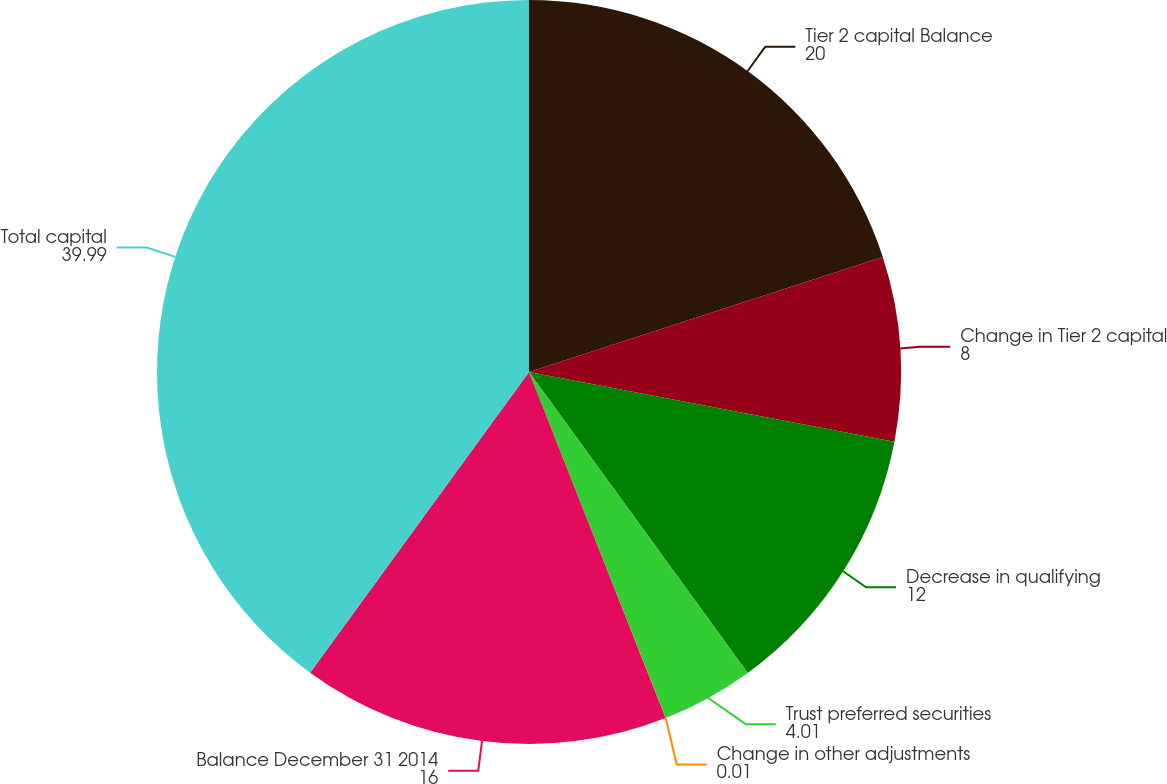<chart> <loc_0><loc_0><loc_500><loc_500><pie_chart><fcel>Tier 2 capital Balance<fcel>Change in Tier 2 capital<fcel>Decrease in qualifying<fcel>Trust preferred securities<fcel>Change in other adjustments<fcel>Balance December 31 2014<fcel>Total capital<nl><fcel>20.0%<fcel>8.0%<fcel>12.0%<fcel>4.01%<fcel>0.01%<fcel>16.0%<fcel>39.99%<nl></chart> 